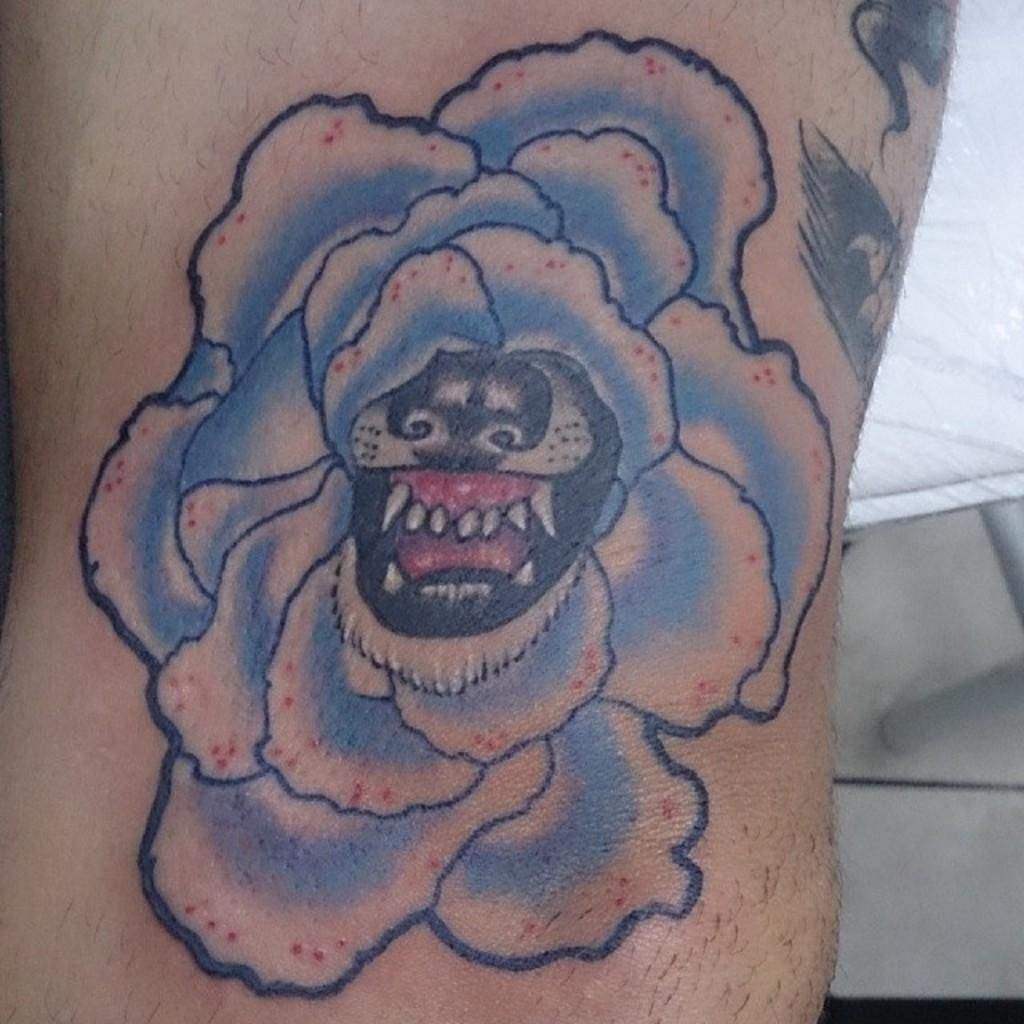What is present on a human body in the image? There is a tattoo on a human body in the image. What colors are used in the tattoo? The tattoo has blue and black colors. What type of shoe is depicted in the tattoo? There is no shoe present in the tattoo; it only features blue and black colors. 